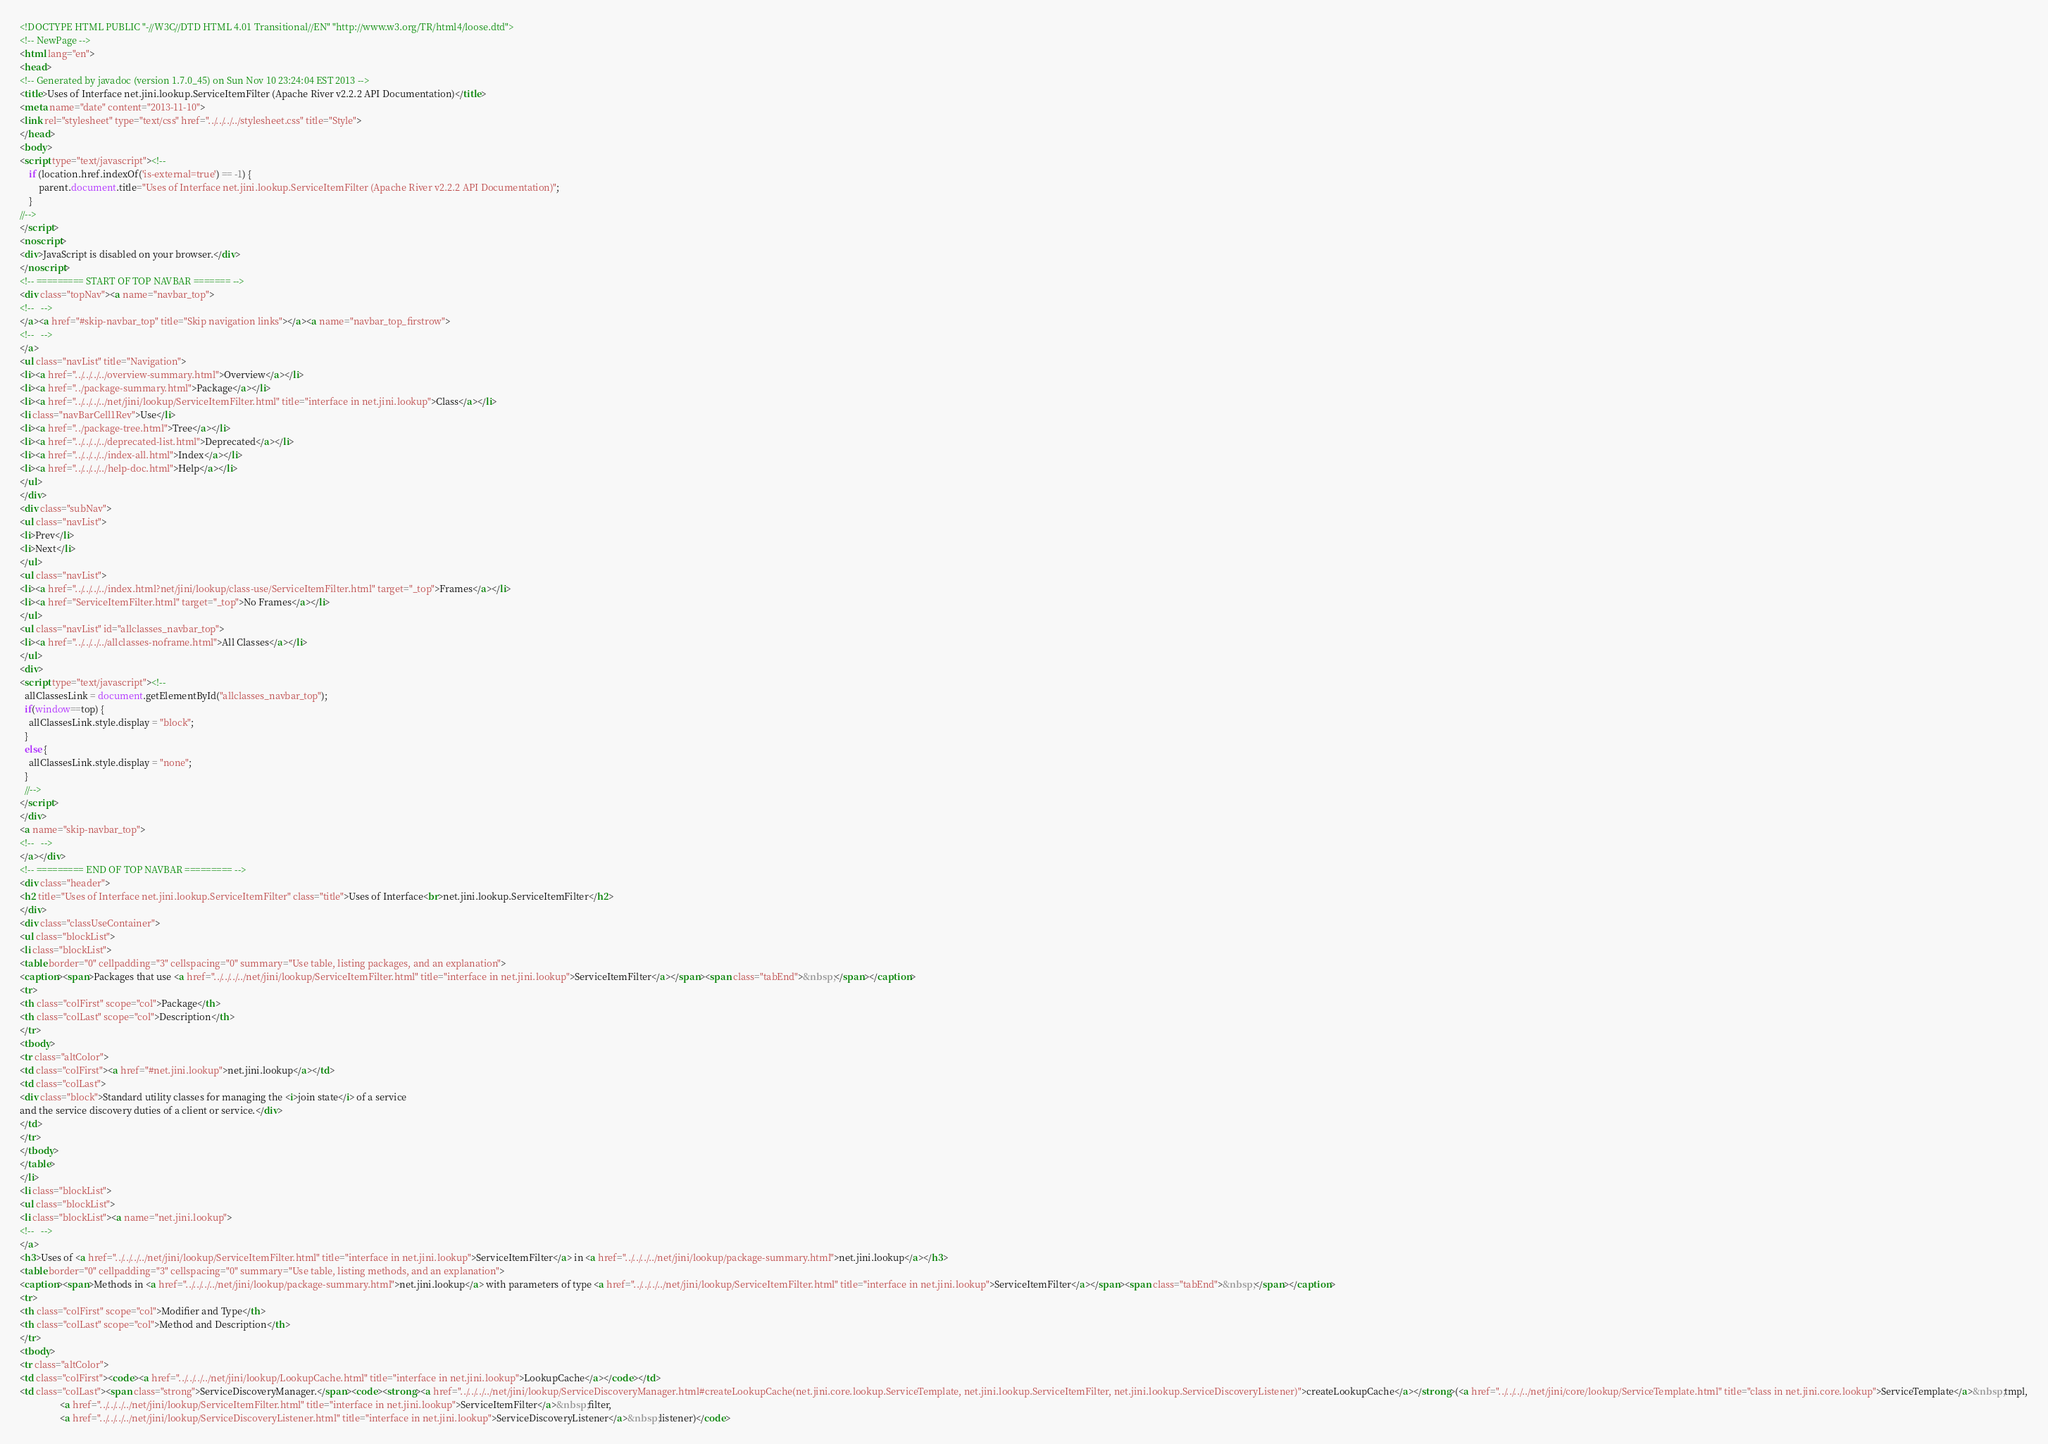Convert code to text. <code><loc_0><loc_0><loc_500><loc_500><_HTML_><!DOCTYPE HTML PUBLIC "-//W3C//DTD HTML 4.01 Transitional//EN" "http://www.w3.org/TR/html4/loose.dtd">
<!-- NewPage -->
<html lang="en">
<head>
<!-- Generated by javadoc (version 1.7.0_45) on Sun Nov 10 23:24:04 EST 2013 -->
<title>Uses of Interface net.jini.lookup.ServiceItemFilter (Apache River v2.2.2 API Documentation)</title>
<meta name="date" content="2013-11-10">
<link rel="stylesheet" type="text/css" href="../../../../stylesheet.css" title="Style">
</head>
<body>
<script type="text/javascript"><!--
    if (location.href.indexOf('is-external=true') == -1) {
        parent.document.title="Uses of Interface net.jini.lookup.ServiceItemFilter (Apache River v2.2.2 API Documentation)";
    }
//-->
</script>
<noscript>
<div>JavaScript is disabled on your browser.</div>
</noscript>
<!-- ========= START OF TOP NAVBAR ======= -->
<div class="topNav"><a name="navbar_top">
<!--   -->
</a><a href="#skip-navbar_top" title="Skip navigation links"></a><a name="navbar_top_firstrow">
<!--   -->
</a>
<ul class="navList" title="Navigation">
<li><a href="../../../../overview-summary.html">Overview</a></li>
<li><a href="../package-summary.html">Package</a></li>
<li><a href="../../../../net/jini/lookup/ServiceItemFilter.html" title="interface in net.jini.lookup">Class</a></li>
<li class="navBarCell1Rev">Use</li>
<li><a href="../package-tree.html">Tree</a></li>
<li><a href="../../../../deprecated-list.html">Deprecated</a></li>
<li><a href="../../../../index-all.html">Index</a></li>
<li><a href="../../../../help-doc.html">Help</a></li>
</ul>
</div>
<div class="subNav">
<ul class="navList">
<li>Prev</li>
<li>Next</li>
</ul>
<ul class="navList">
<li><a href="../../../../index.html?net/jini/lookup/class-use/ServiceItemFilter.html" target="_top">Frames</a></li>
<li><a href="ServiceItemFilter.html" target="_top">No Frames</a></li>
</ul>
<ul class="navList" id="allclasses_navbar_top">
<li><a href="../../../../allclasses-noframe.html">All Classes</a></li>
</ul>
<div>
<script type="text/javascript"><!--
  allClassesLink = document.getElementById("allclasses_navbar_top");
  if(window==top) {
    allClassesLink.style.display = "block";
  }
  else {
    allClassesLink.style.display = "none";
  }
  //-->
</script>
</div>
<a name="skip-navbar_top">
<!--   -->
</a></div>
<!-- ========= END OF TOP NAVBAR ========= -->
<div class="header">
<h2 title="Uses of Interface net.jini.lookup.ServiceItemFilter" class="title">Uses of Interface<br>net.jini.lookup.ServiceItemFilter</h2>
</div>
<div class="classUseContainer">
<ul class="blockList">
<li class="blockList">
<table border="0" cellpadding="3" cellspacing="0" summary="Use table, listing packages, and an explanation">
<caption><span>Packages that use <a href="../../../../net/jini/lookup/ServiceItemFilter.html" title="interface in net.jini.lookup">ServiceItemFilter</a></span><span class="tabEnd">&nbsp;</span></caption>
<tr>
<th class="colFirst" scope="col">Package</th>
<th class="colLast" scope="col">Description</th>
</tr>
<tbody>
<tr class="altColor">
<td class="colFirst"><a href="#net.jini.lookup">net.jini.lookup</a></td>
<td class="colLast">
<div class="block">Standard utility classes for managing the <i>join state</i> of a service
and the service discovery duties of a client or service.</div>
</td>
</tr>
</tbody>
</table>
</li>
<li class="blockList">
<ul class="blockList">
<li class="blockList"><a name="net.jini.lookup">
<!--   -->
</a>
<h3>Uses of <a href="../../../../net/jini/lookup/ServiceItemFilter.html" title="interface in net.jini.lookup">ServiceItemFilter</a> in <a href="../../../../net/jini/lookup/package-summary.html">net.jini.lookup</a></h3>
<table border="0" cellpadding="3" cellspacing="0" summary="Use table, listing methods, and an explanation">
<caption><span>Methods in <a href="../../../../net/jini/lookup/package-summary.html">net.jini.lookup</a> with parameters of type <a href="../../../../net/jini/lookup/ServiceItemFilter.html" title="interface in net.jini.lookup">ServiceItemFilter</a></span><span class="tabEnd">&nbsp;</span></caption>
<tr>
<th class="colFirst" scope="col">Modifier and Type</th>
<th class="colLast" scope="col">Method and Description</th>
</tr>
<tbody>
<tr class="altColor">
<td class="colFirst"><code><a href="../../../../net/jini/lookup/LookupCache.html" title="interface in net.jini.lookup">LookupCache</a></code></td>
<td class="colLast"><span class="strong">ServiceDiscoveryManager.</span><code><strong><a href="../../../../net/jini/lookup/ServiceDiscoveryManager.html#createLookupCache(net.jini.core.lookup.ServiceTemplate, net.jini.lookup.ServiceItemFilter, net.jini.lookup.ServiceDiscoveryListener)">createLookupCache</a></strong>(<a href="../../../../net/jini/core/lookup/ServiceTemplate.html" title="class in net.jini.core.lookup">ServiceTemplate</a>&nbsp;tmpl,
                 <a href="../../../../net/jini/lookup/ServiceItemFilter.html" title="interface in net.jini.lookup">ServiceItemFilter</a>&nbsp;filter,
                 <a href="../../../../net/jini/lookup/ServiceDiscoveryListener.html" title="interface in net.jini.lookup">ServiceDiscoveryListener</a>&nbsp;listener)</code></code> 